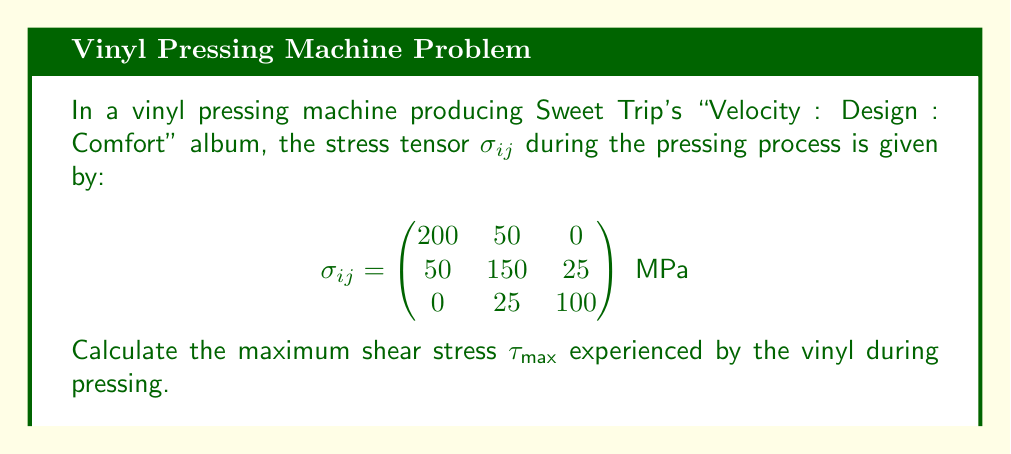Give your solution to this math problem. To find the maximum shear stress, we need to follow these steps:

1) First, we need to calculate the principal stresses. These are the eigenvalues of the stress tensor.

2) The characteristic equation for the eigenvalues λ is:
   $$\det(\sigma_{ij} - \lambda I) = 0$$

3) Expanding this determinant:
   $$(200-\lambda)(150-\lambda)(100-\lambda) - 50^2(100-\lambda) - 25^2(200-\lambda) - 0 = 0$$

4) This simplifies to:
   $$-\lambda^3 + 450\lambda^2 - 66875\lambda + 3250000 = 0$$

5) Solving this cubic equation (which can be done numerically) gives us the principal stresses:
   $$\lambda_1 \approx 227.8 \text{ MPa}, \lambda_2 \approx 133.6 \text{ MPa}, \lambda_3 \approx 88.6 \text{ MPa}$$

6) The maximum shear stress is given by:
   $$\tau_{\text{max}} = \frac{\lambda_1 - \lambda_3}{2}$$

7) Substituting the values:
   $$\tau_{\text{max}} = \frac{227.8 - 88.6}{2} = 69.6 \text{ MPa}$$

Therefore, the maximum shear stress experienced by the vinyl during pressing is approximately 69.6 MPa.
Answer: $\tau_{\text{max}} \approx 69.6 \text{ MPa}$ 